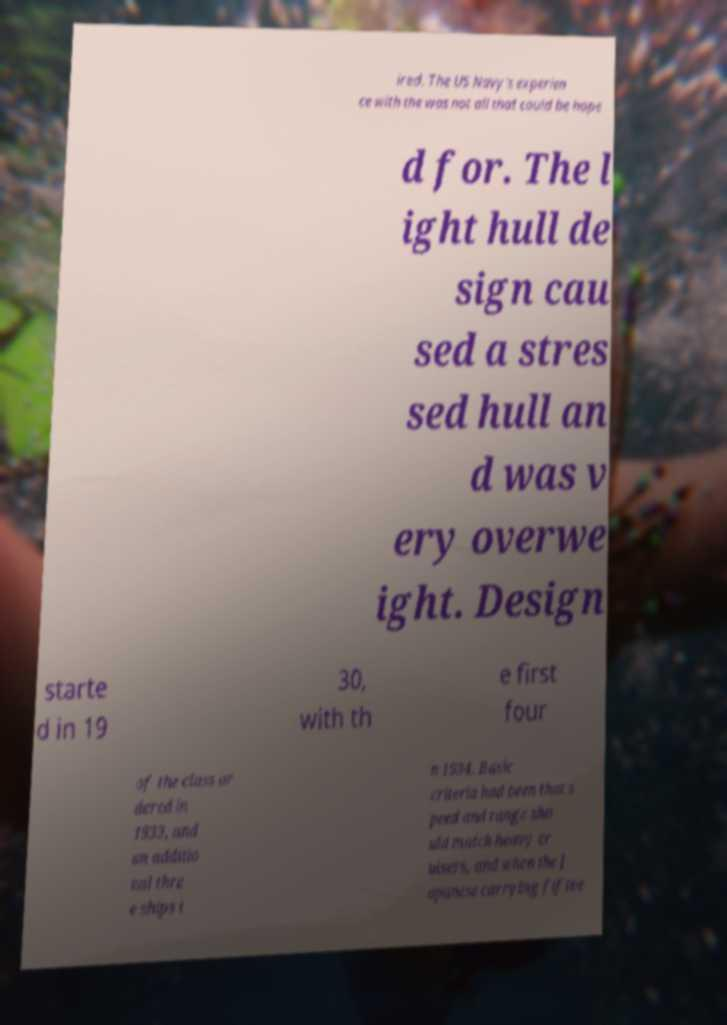Could you extract and type out the text from this image? ired. The US Navy's experien ce with the was not all that could be hope d for. The l ight hull de sign cau sed a stres sed hull an d was v ery overwe ight. Design starte d in 19 30, with th e first four of the class or dered in 1933, and an additio nal thre e ships i n 1934. Basic criteria had been that s peed and range sho uld match heavy cr uisers, and when the J apanese carrying fiftee 